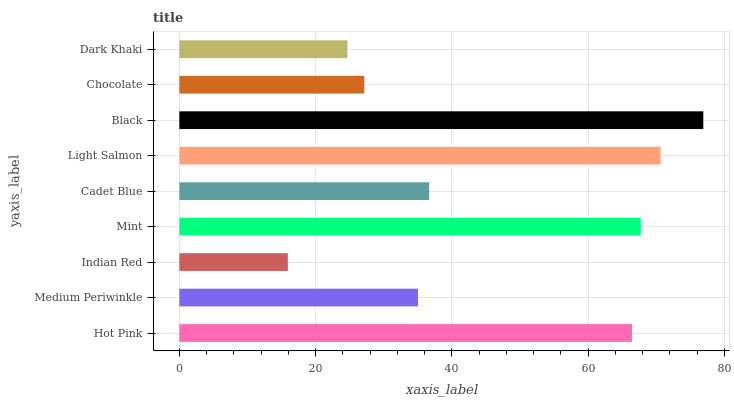Is Indian Red the minimum?
Answer yes or no. Yes. Is Black the maximum?
Answer yes or no. Yes. Is Medium Periwinkle the minimum?
Answer yes or no. No. Is Medium Periwinkle the maximum?
Answer yes or no. No. Is Hot Pink greater than Medium Periwinkle?
Answer yes or no. Yes. Is Medium Periwinkle less than Hot Pink?
Answer yes or no. Yes. Is Medium Periwinkle greater than Hot Pink?
Answer yes or no. No. Is Hot Pink less than Medium Periwinkle?
Answer yes or no. No. Is Cadet Blue the high median?
Answer yes or no. Yes. Is Cadet Blue the low median?
Answer yes or no. Yes. Is Indian Red the high median?
Answer yes or no. No. Is Hot Pink the low median?
Answer yes or no. No. 